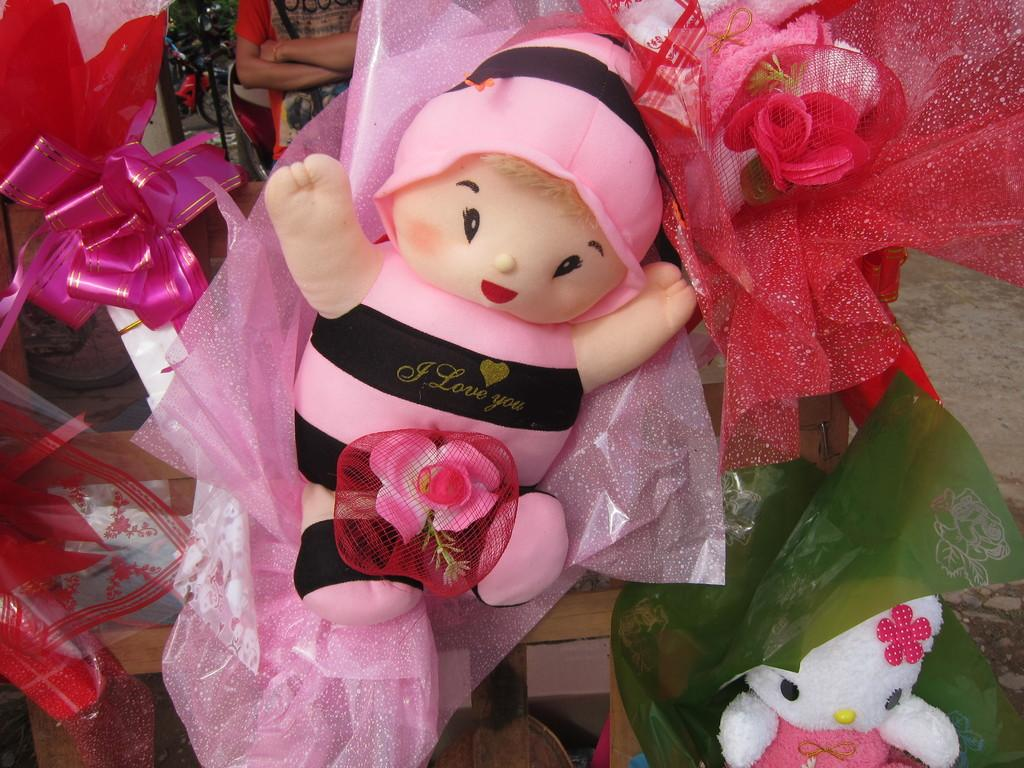How many dolls are present in the image? There are two dolls in the image. What else can be seen in the image besides the dolls? There are decorative wrappers in the image. Can you describe the person behind the doll in the image? The person is not clearly visible, but their presence is indicated behind the doll. What type of mist can be seen surrounding the dolls in the image? There is no mist present in the image; it is a clear scene with dolls and decorative wrappers. 